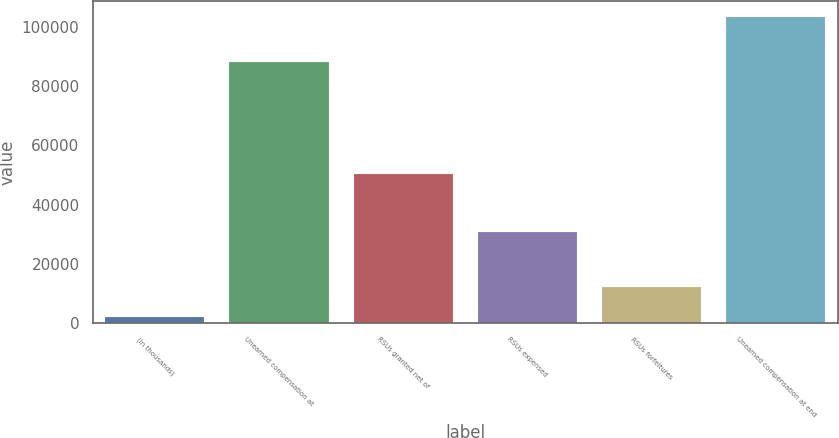Convert chart. <chart><loc_0><loc_0><loc_500><loc_500><bar_chart><fcel>(In thousands)<fcel>Unearned compensation at<fcel>RSUs granted net of<fcel>RSUs expensed<fcel>RSUs forfeitures<fcel>Unearned compensation at end<nl><fcel>2015<fcel>88015<fcel>50442<fcel>30691<fcel>12167.3<fcel>103538<nl></chart> 